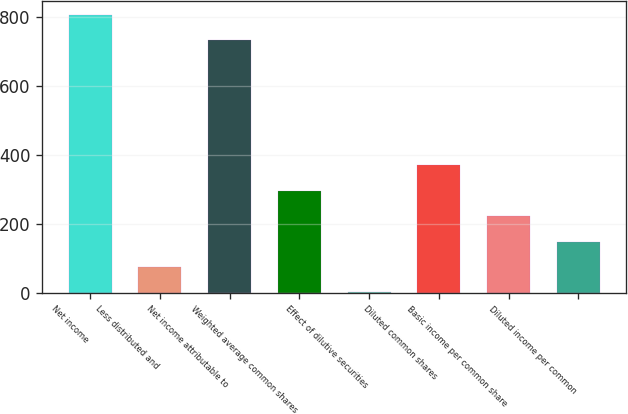Convert chart. <chart><loc_0><loc_0><loc_500><loc_500><bar_chart><fcel>Net income<fcel>Less distributed and<fcel>Net income attributable to<fcel>Weighted average common shares<fcel>Effect of dilutive securities<fcel>Diluted common shares<fcel>Basic income per common share<fcel>Diluted income per common<nl><fcel>806.08<fcel>73.98<fcel>732.3<fcel>295.32<fcel>0.2<fcel>369.1<fcel>221.54<fcel>147.76<nl></chart> 